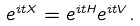Convert formula to latex. <formula><loc_0><loc_0><loc_500><loc_500>e ^ { i t X } = e ^ { i t H } e ^ { i t V } .</formula> 